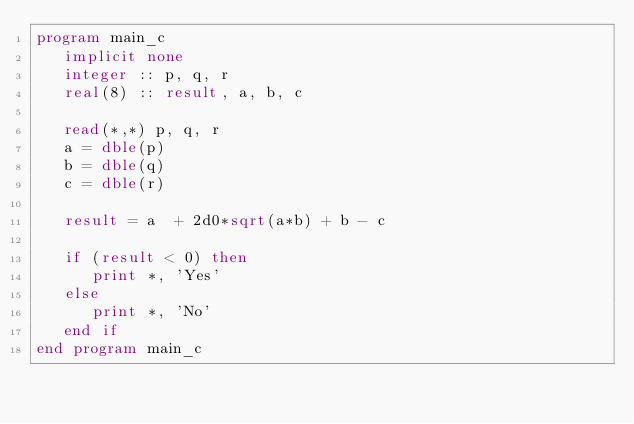<code> <loc_0><loc_0><loc_500><loc_500><_FORTRAN_>program main_c
   implicit none
   integer :: p, q, r
   real(8) :: result, a, b, c

   read(*,*) p, q, r
   a = dble(p)
   b = dble(q)
   c = dble(r)

   result = a  + 2d0*sqrt(a*b) + b - c

   if (result < 0) then
      print *, 'Yes'
   else
      print *, 'No'
   end if
end program main_c
</code> 